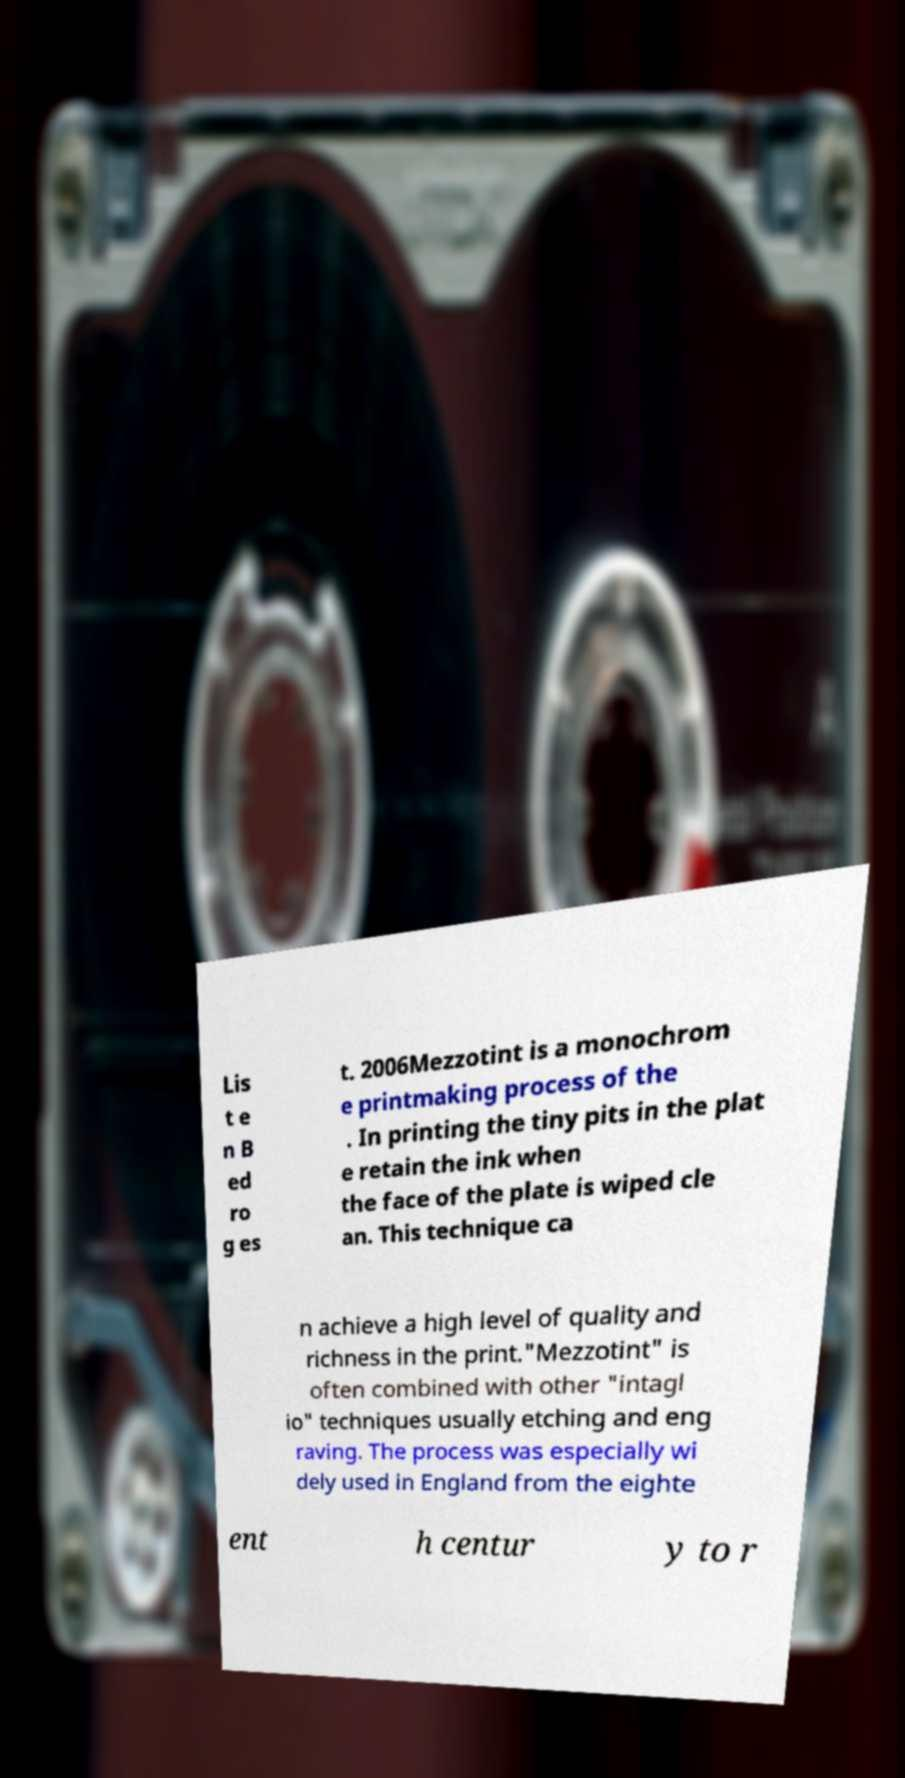For documentation purposes, I need the text within this image transcribed. Could you provide that? Lis t e n B ed ro g es t. 2006Mezzotint is a monochrom e printmaking process of the . In printing the tiny pits in the plat e retain the ink when the face of the plate is wiped cle an. This technique ca n achieve a high level of quality and richness in the print."Mezzotint" is often combined with other "intagl io" techniques usually etching and eng raving. The process was especially wi dely used in England from the eighte ent h centur y to r 